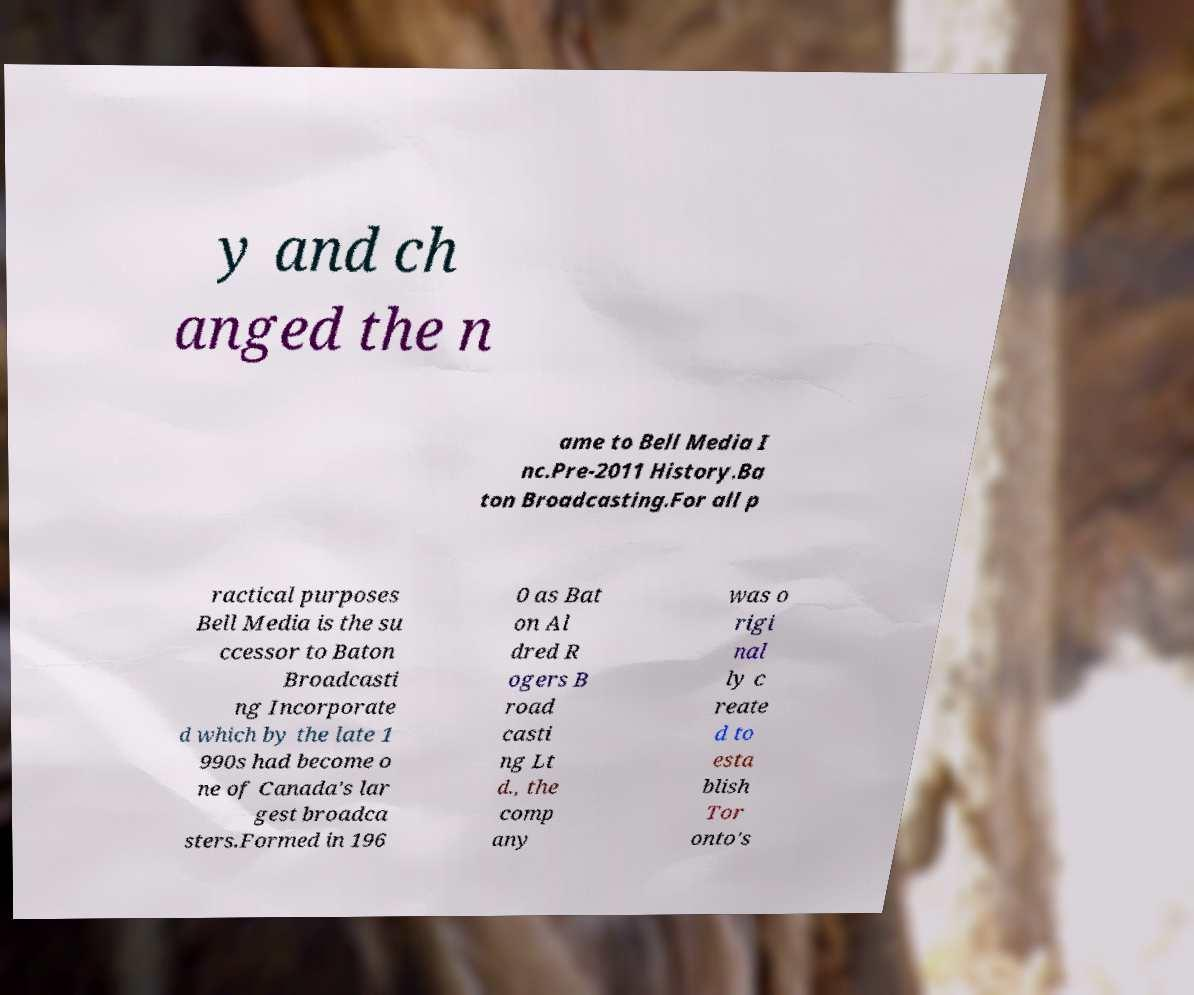Please identify and transcribe the text found in this image. y and ch anged the n ame to Bell Media I nc.Pre-2011 History.Ba ton Broadcasting.For all p ractical purposes Bell Media is the su ccessor to Baton Broadcasti ng Incorporate d which by the late 1 990s had become o ne of Canada's lar gest broadca sters.Formed in 196 0 as Bat on Al dred R ogers B road casti ng Lt d., the comp any was o rigi nal ly c reate d to esta blish Tor onto's 